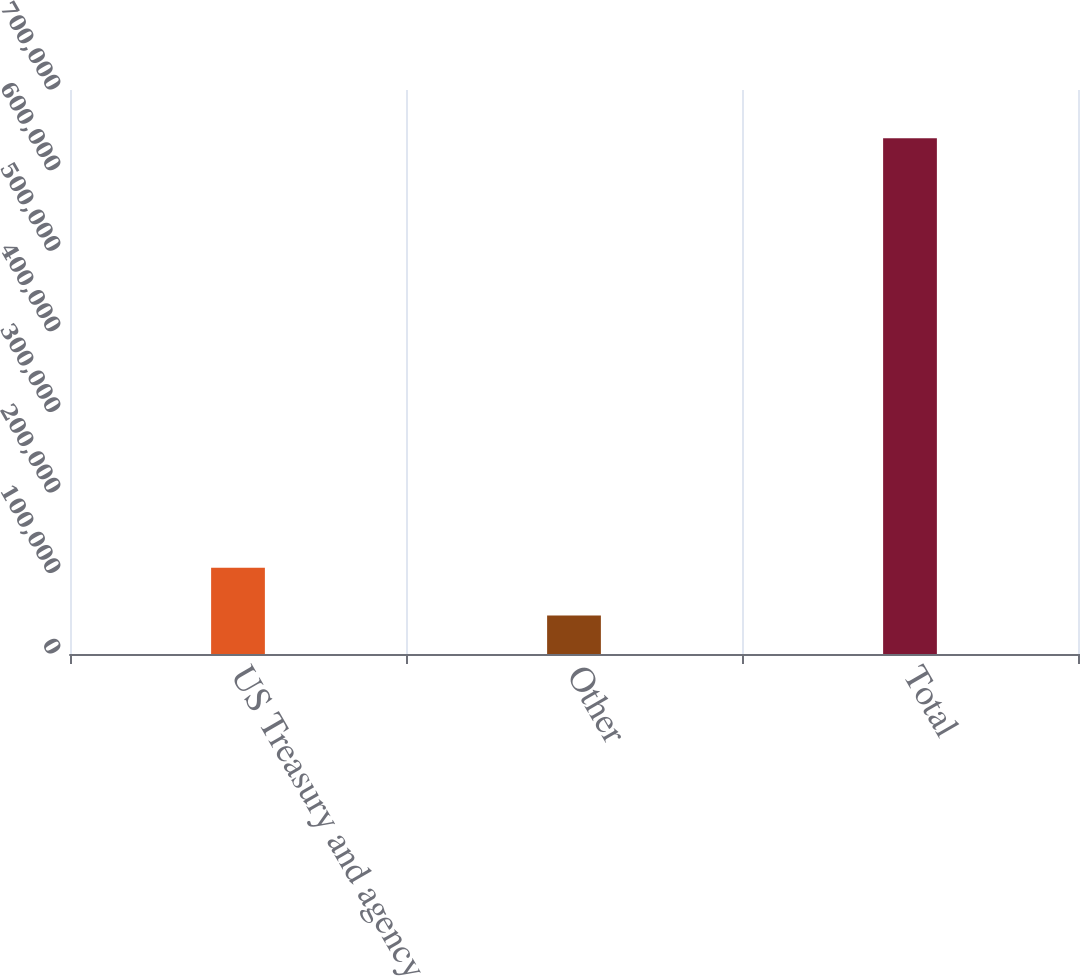Convert chart. <chart><loc_0><loc_0><loc_500><loc_500><bar_chart><fcel>US Treasury and agency<fcel>Other<fcel>Total<nl><fcel>107081<fcel>47847<fcel>640191<nl></chart> 